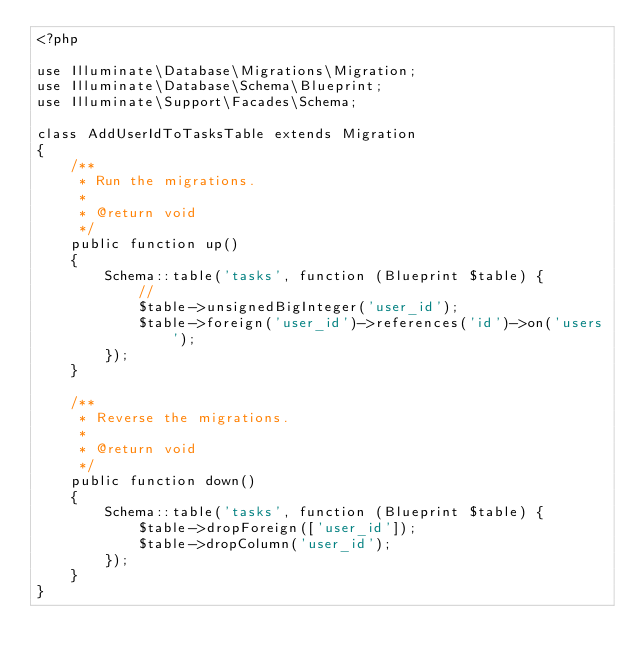Convert code to text. <code><loc_0><loc_0><loc_500><loc_500><_PHP_><?php

use Illuminate\Database\Migrations\Migration;
use Illuminate\Database\Schema\Blueprint;
use Illuminate\Support\Facades\Schema;

class AddUserIdToTasksTable extends Migration
{
    /**
     * Run the migrations.
     *
     * @return void
     */
    public function up()
    {
        Schema::table('tasks', function (Blueprint $table) {
            //
            $table->unsignedBigInteger('user_id');
            $table->foreign('user_id')->references('id')->on('users');
        });
    }

    /**
     * Reverse the migrations.
     *
     * @return void
     */
    public function down()
    {
        Schema::table('tasks', function (Blueprint $table) {
            $table->dropForeign(['user_id']);
            $table->dropColumn('user_id');
        });
    }
}
</code> 